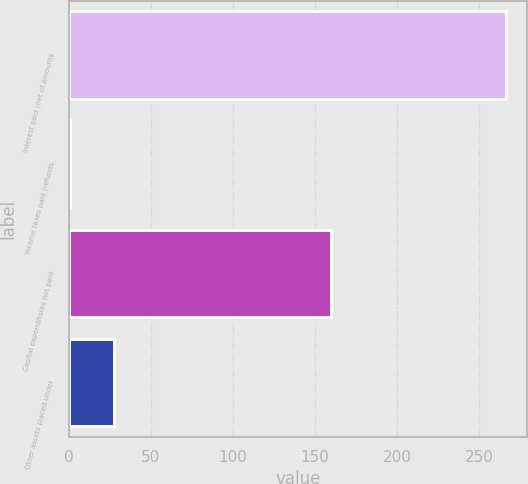Convert chart. <chart><loc_0><loc_0><loc_500><loc_500><bar_chart><fcel>Interest paid (net of amounts<fcel>Income taxes paid (refunds<fcel>Capital expenditures not paid<fcel>Other assets placed under<nl><fcel>266<fcel>1<fcel>160<fcel>27.5<nl></chart> 